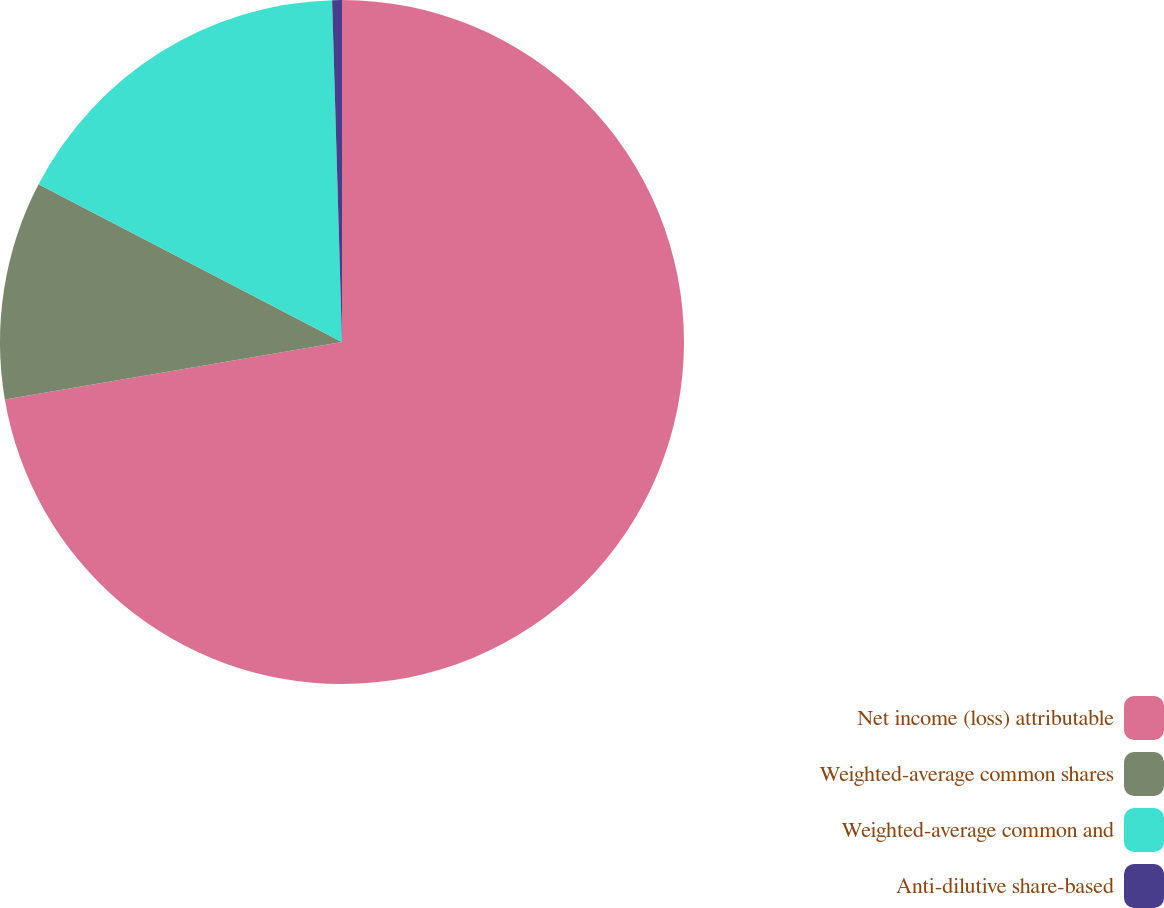Convert chart. <chart><loc_0><loc_0><loc_500><loc_500><pie_chart><fcel>Net income (loss) attributable<fcel>Weighted-average common shares<fcel>Weighted-average common and<fcel>Anti-dilutive share-based<nl><fcel>72.31%<fcel>10.31%<fcel>16.91%<fcel>0.46%<nl></chart> 